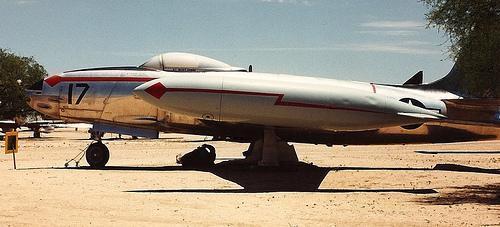How many cockpits are there?
Give a very brief answer. 1. 